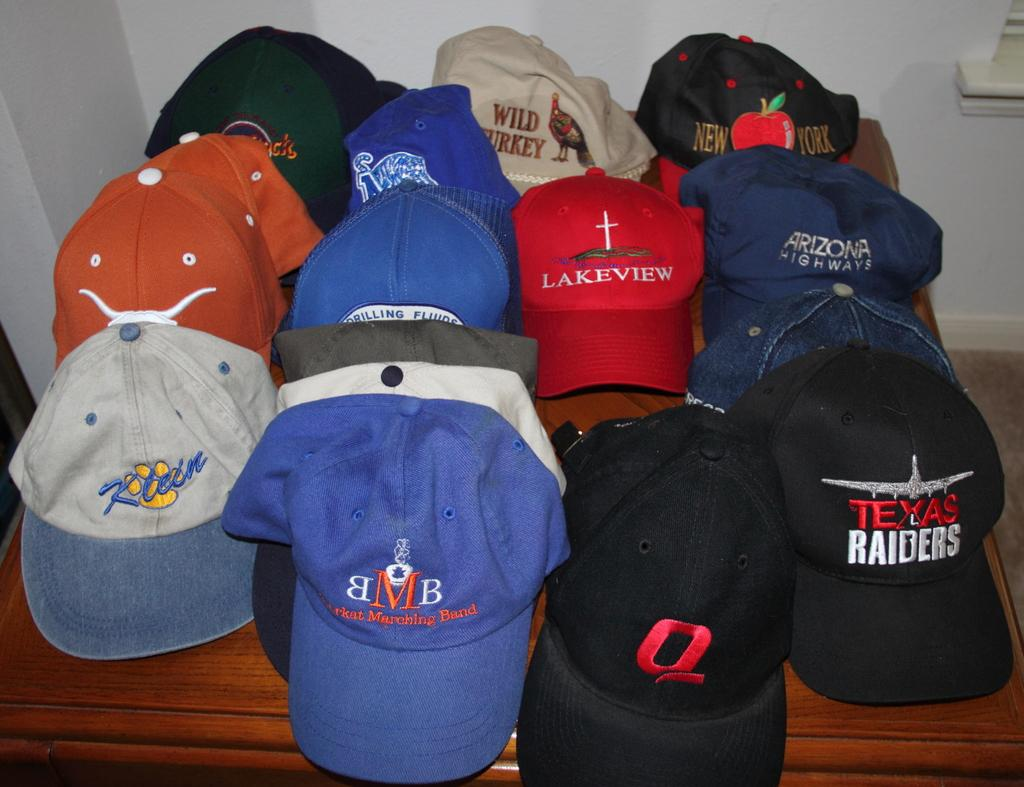<image>
Render a clear and concise summary of the photo. The black hat on the right is for the Texas Raiders 